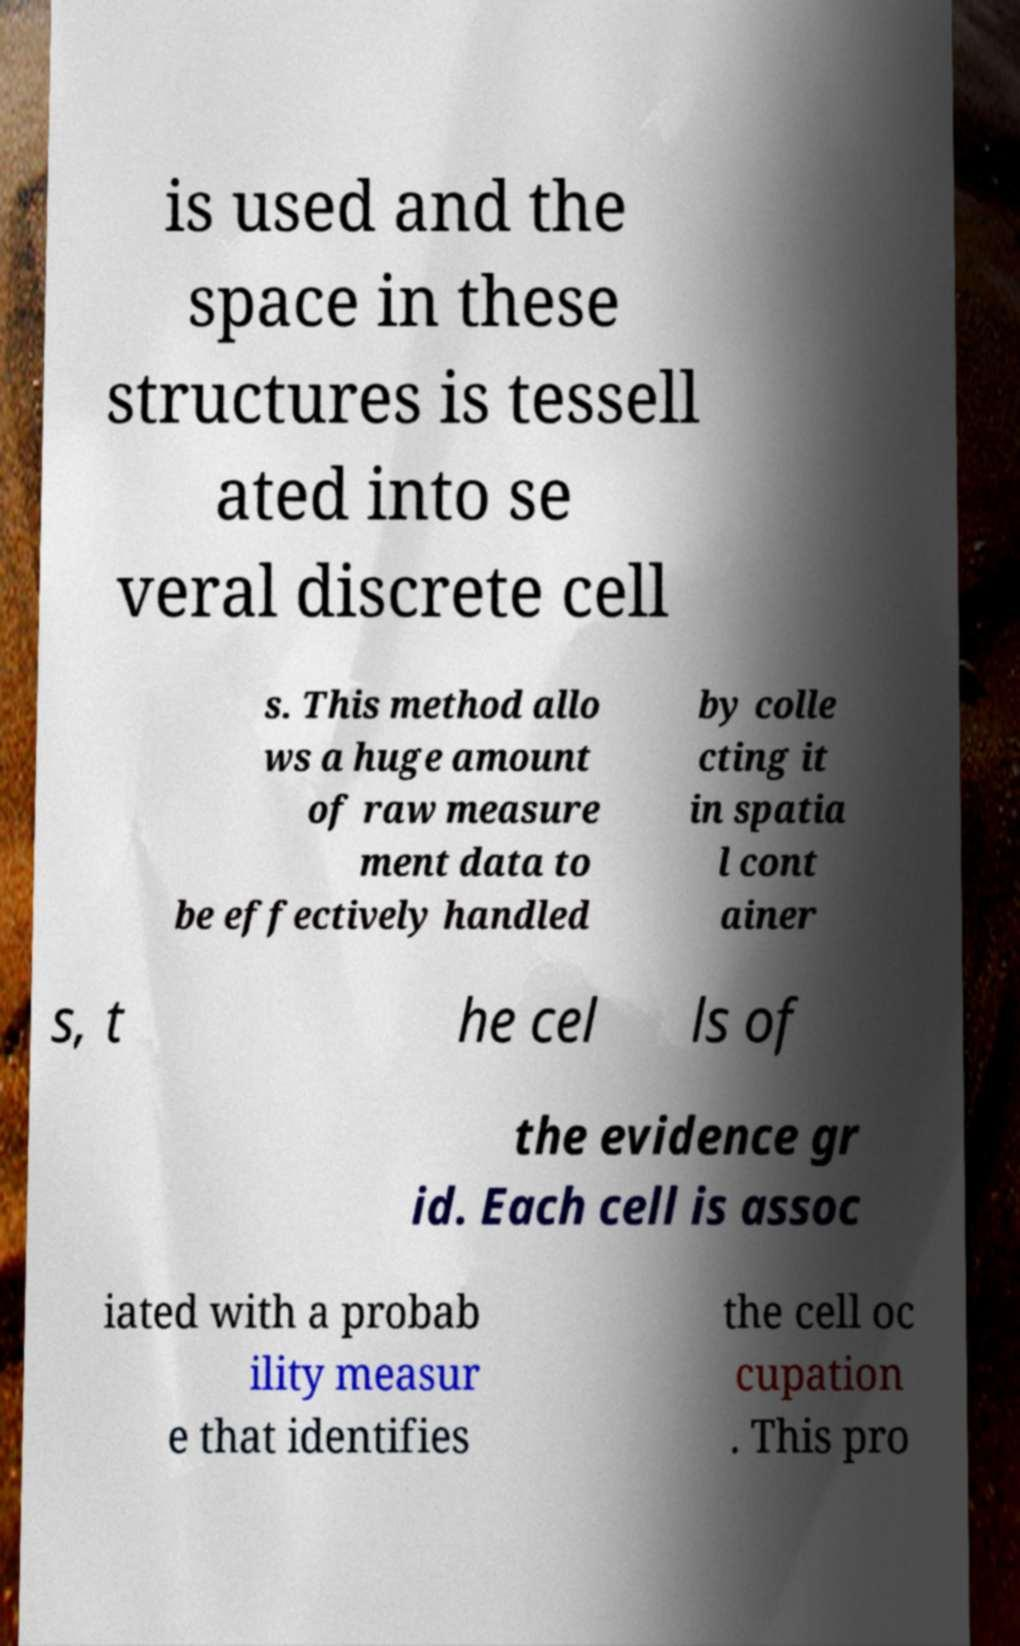Please read and relay the text visible in this image. What does it say? is used and the space in these structures is tessell ated into se veral discrete cell s. This method allo ws a huge amount of raw measure ment data to be effectively handled by colle cting it in spatia l cont ainer s, t he cel ls of the evidence gr id. Each cell is assoc iated with a probab ility measur e that identifies the cell oc cupation . This pro 